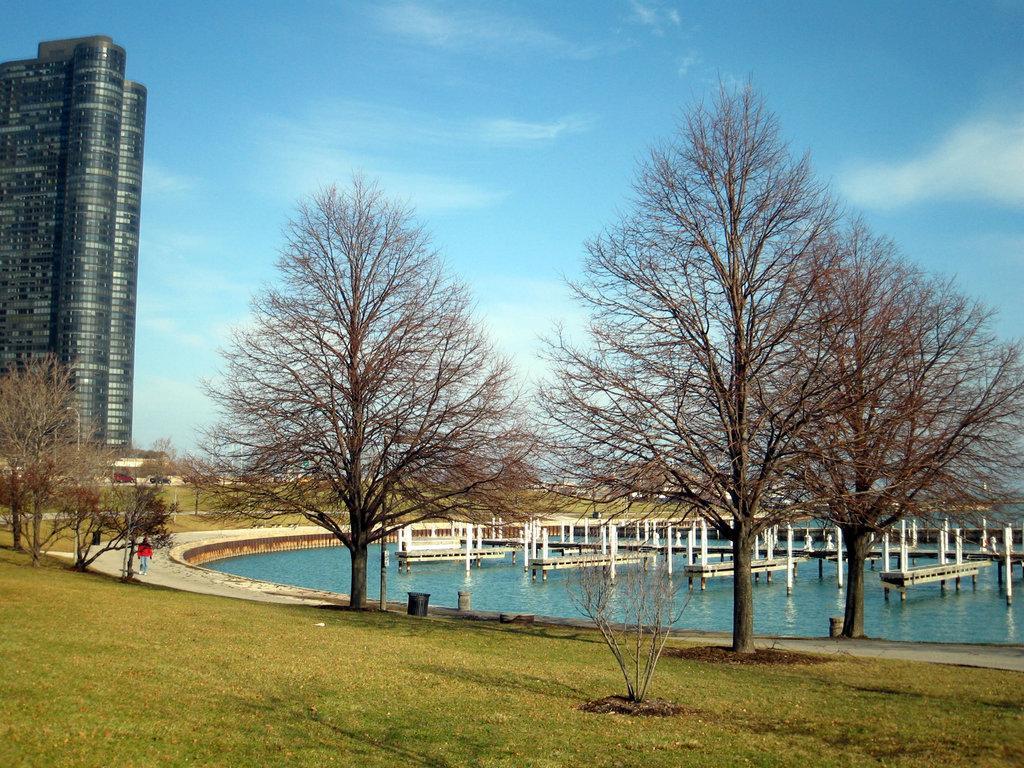Please provide a concise description of this image. In this image, we can see so many trees, poles, walkway, grass, plants, dustbins. Background there is a sky. On the left side of the image, we can see a buildings. Here we can see a person on the walkway. 